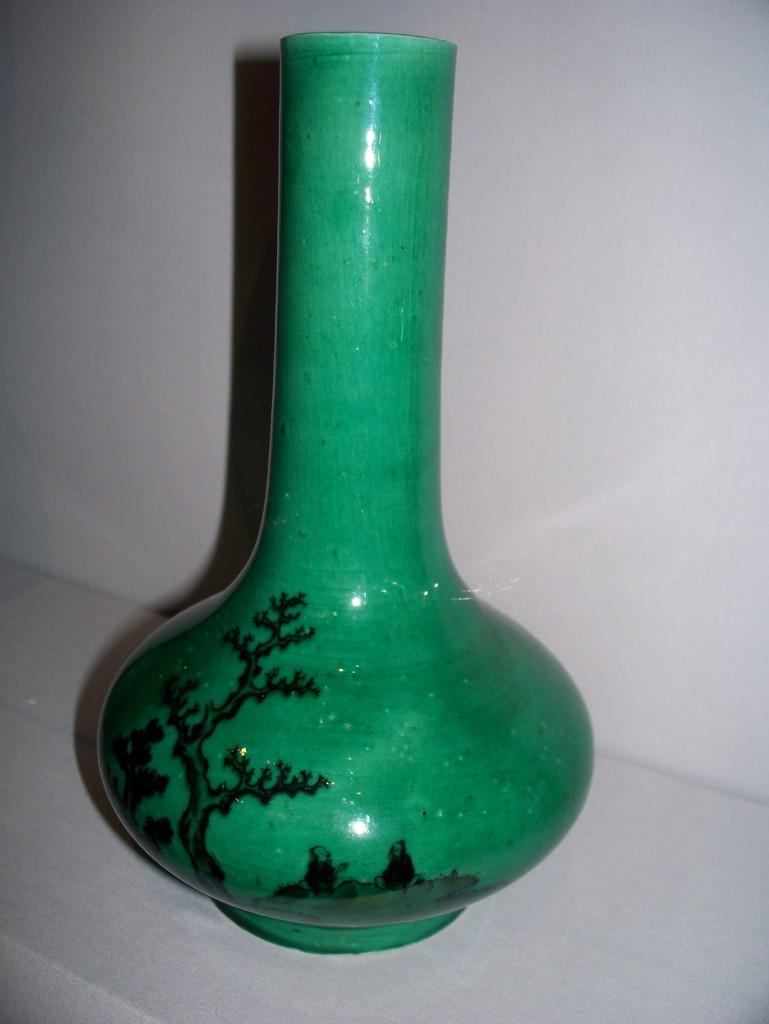What is the color of the vase in the image? The vase is green in the image. What can be seen on the surface of the vase? The vase has a design on it. Where is the vase located in the image? The vase is on a platform. What is visible in the background of the image? There is a wall in the background of the image. What type of letter is being delivered to the vase in the image? There is no letter or delivery depicted in the image; it only features a green vase on a platform with a wall in the background. 